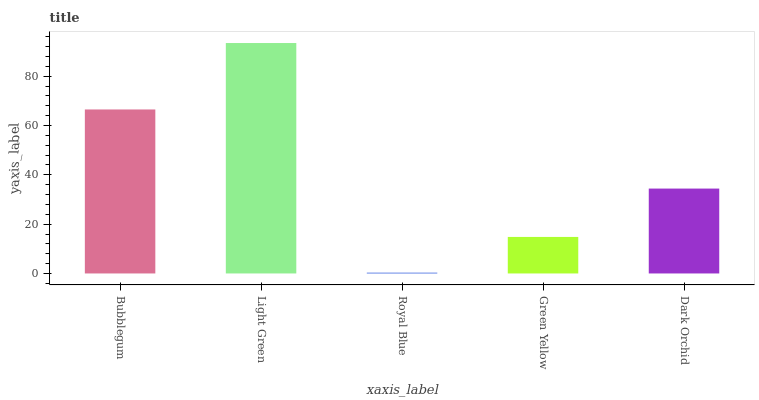Is Light Green the minimum?
Answer yes or no. No. Is Royal Blue the maximum?
Answer yes or no. No. Is Light Green greater than Royal Blue?
Answer yes or no. Yes. Is Royal Blue less than Light Green?
Answer yes or no. Yes. Is Royal Blue greater than Light Green?
Answer yes or no. No. Is Light Green less than Royal Blue?
Answer yes or no. No. Is Dark Orchid the high median?
Answer yes or no. Yes. Is Dark Orchid the low median?
Answer yes or no. Yes. Is Light Green the high median?
Answer yes or no. No. Is Green Yellow the low median?
Answer yes or no. No. 